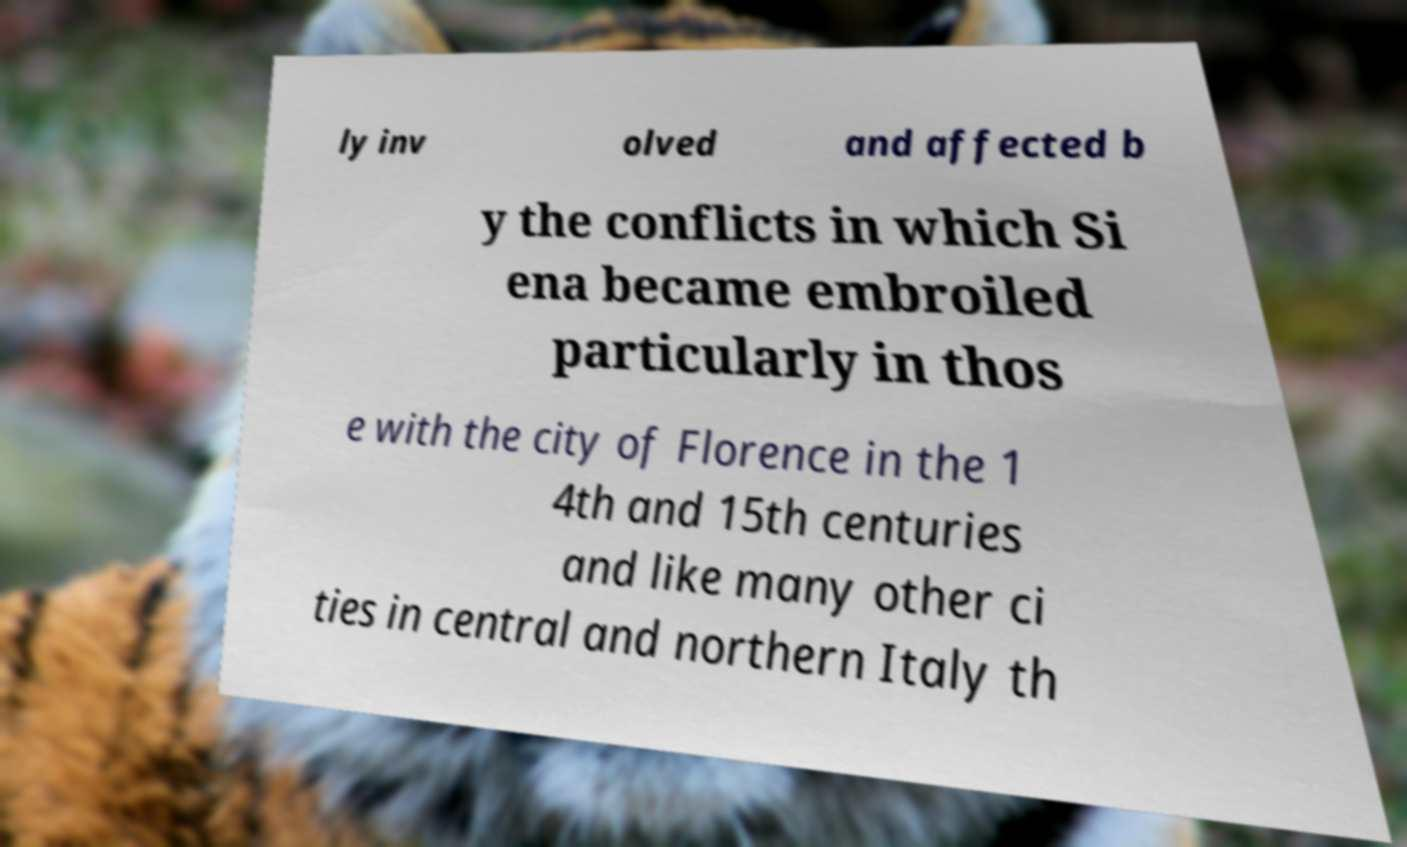I need the written content from this picture converted into text. Can you do that? ly inv olved and affected b y the conflicts in which Si ena became embroiled particularly in thos e with the city of Florence in the 1 4th and 15th centuries and like many other ci ties in central and northern Italy th 